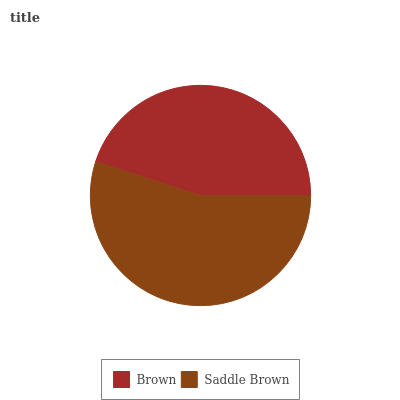Is Brown the minimum?
Answer yes or no. Yes. Is Saddle Brown the maximum?
Answer yes or no. Yes. Is Saddle Brown the minimum?
Answer yes or no. No. Is Saddle Brown greater than Brown?
Answer yes or no. Yes. Is Brown less than Saddle Brown?
Answer yes or no. Yes. Is Brown greater than Saddle Brown?
Answer yes or no. No. Is Saddle Brown less than Brown?
Answer yes or no. No. Is Saddle Brown the high median?
Answer yes or no. Yes. Is Brown the low median?
Answer yes or no. Yes. Is Brown the high median?
Answer yes or no. No. Is Saddle Brown the low median?
Answer yes or no. No. 